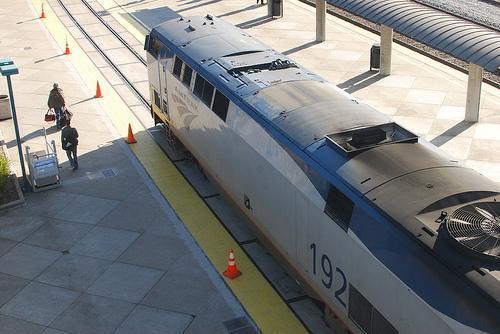How many people are there?
Give a very brief answer. 2. 